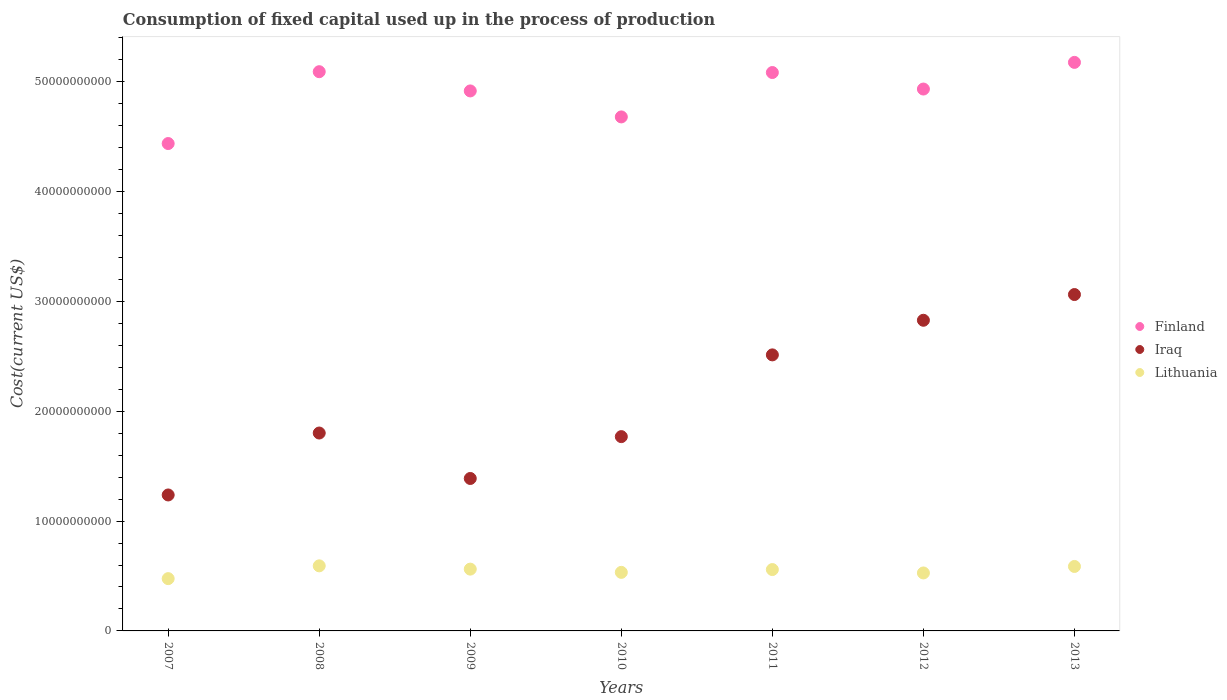Is the number of dotlines equal to the number of legend labels?
Keep it short and to the point. Yes. What is the amount consumed in the process of production in Iraq in 2008?
Keep it short and to the point. 1.80e+1. Across all years, what is the maximum amount consumed in the process of production in Lithuania?
Give a very brief answer. 5.93e+09. Across all years, what is the minimum amount consumed in the process of production in Lithuania?
Keep it short and to the point. 4.76e+09. In which year was the amount consumed in the process of production in Iraq maximum?
Make the answer very short. 2013. In which year was the amount consumed in the process of production in Lithuania minimum?
Provide a succinct answer. 2007. What is the total amount consumed in the process of production in Lithuania in the graph?
Make the answer very short. 3.84e+1. What is the difference between the amount consumed in the process of production in Finland in 2011 and that in 2012?
Give a very brief answer. 1.50e+09. What is the difference between the amount consumed in the process of production in Finland in 2011 and the amount consumed in the process of production in Lithuania in 2007?
Keep it short and to the point. 4.61e+1. What is the average amount consumed in the process of production in Iraq per year?
Make the answer very short. 2.09e+1. In the year 2012, what is the difference between the amount consumed in the process of production in Finland and amount consumed in the process of production in Lithuania?
Ensure brevity in your answer.  4.41e+1. What is the ratio of the amount consumed in the process of production in Iraq in 2008 to that in 2013?
Keep it short and to the point. 0.59. Is the amount consumed in the process of production in Iraq in 2008 less than that in 2013?
Give a very brief answer. Yes. Is the difference between the amount consumed in the process of production in Finland in 2009 and 2012 greater than the difference between the amount consumed in the process of production in Lithuania in 2009 and 2012?
Offer a very short reply. No. What is the difference between the highest and the second highest amount consumed in the process of production in Lithuania?
Your answer should be very brief. 5.58e+07. What is the difference between the highest and the lowest amount consumed in the process of production in Lithuania?
Make the answer very short. 1.16e+09. In how many years, is the amount consumed in the process of production in Finland greater than the average amount consumed in the process of production in Finland taken over all years?
Keep it short and to the point. 5. Does the amount consumed in the process of production in Iraq monotonically increase over the years?
Provide a succinct answer. No. How many dotlines are there?
Offer a terse response. 3. How many years are there in the graph?
Keep it short and to the point. 7. What is the difference between two consecutive major ticks on the Y-axis?
Keep it short and to the point. 1.00e+1. Where does the legend appear in the graph?
Your answer should be compact. Center right. How are the legend labels stacked?
Provide a short and direct response. Vertical. What is the title of the graph?
Your answer should be compact. Consumption of fixed capital used up in the process of production. What is the label or title of the Y-axis?
Provide a short and direct response. Cost(current US$). What is the Cost(current US$) of Finland in 2007?
Your answer should be compact. 4.44e+1. What is the Cost(current US$) in Iraq in 2007?
Your response must be concise. 1.24e+1. What is the Cost(current US$) in Lithuania in 2007?
Offer a terse response. 4.76e+09. What is the Cost(current US$) of Finland in 2008?
Offer a terse response. 5.09e+1. What is the Cost(current US$) of Iraq in 2008?
Provide a short and direct response. 1.80e+1. What is the Cost(current US$) of Lithuania in 2008?
Keep it short and to the point. 5.93e+09. What is the Cost(current US$) of Finland in 2009?
Provide a short and direct response. 4.92e+1. What is the Cost(current US$) in Iraq in 2009?
Keep it short and to the point. 1.39e+1. What is the Cost(current US$) of Lithuania in 2009?
Your answer should be compact. 5.63e+09. What is the Cost(current US$) in Finland in 2010?
Ensure brevity in your answer.  4.68e+1. What is the Cost(current US$) of Iraq in 2010?
Make the answer very short. 1.77e+1. What is the Cost(current US$) in Lithuania in 2010?
Your answer should be very brief. 5.33e+09. What is the Cost(current US$) in Finland in 2011?
Provide a succinct answer. 5.08e+1. What is the Cost(current US$) in Iraq in 2011?
Your answer should be very brief. 2.51e+1. What is the Cost(current US$) of Lithuania in 2011?
Ensure brevity in your answer.  5.59e+09. What is the Cost(current US$) of Finland in 2012?
Your answer should be compact. 4.93e+1. What is the Cost(current US$) of Iraq in 2012?
Offer a very short reply. 2.83e+1. What is the Cost(current US$) of Lithuania in 2012?
Provide a short and direct response. 5.28e+09. What is the Cost(current US$) in Finland in 2013?
Your response must be concise. 5.18e+1. What is the Cost(current US$) of Iraq in 2013?
Provide a short and direct response. 3.06e+1. What is the Cost(current US$) of Lithuania in 2013?
Your answer should be very brief. 5.87e+09. Across all years, what is the maximum Cost(current US$) of Finland?
Make the answer very short. 5.18e+1. Across all years, what is the maximum Cost(current US$) of Iraq?
Make the answer very short. 3.06e+1. Across all years, what is the maximum Cost(current US$) of Lithuania?
Provide a short and direct response. 5.93e+09. Across all years, what is the minimum Cost(current US$) in Finland?
Keep it short and to the point. 4.44e+1. Across all years, what is the minimum Cost(current US$) of Iraq?
Keep it short and to the point. 1.24e+1. Across all years, what is the minimum Cost(current US$) in Lithuania?
Offer a very short reply. 4.76e+09. What is the total Cost(current US$) in Finland in the graph?
Make the answer very short. 3.43e+11. What is the total Cost(current US$) of Iraq in the graph?
Offer a terse response. 1.46e+11. What is the total Cost(current US$) of Lithuania in the graph?
Keep it short and to the point. 3.84e+1. What is the difference between the Cost(current US$) in Finland in 2007 and that in 2008?
Your answer should be compact. -6.54e+09. What is the difference between the Cost(current US$) in Iraq in 2007 and that in 2008?
Keep it short and to the point. -5.64e+09. What is the difference between the Cost(current US$) of Lithuania in 2007 and that in 2008?
Provide a short and direct response. -1.16e+09. What is the difference between the Cost(current US$) in Finland in 2007 and that in 2009?
Provide a succinct answer. -4.79e+09. What is the difference between the Cost(current US$) in Iraq in 2007 and that in 2009?
Offer a very short reply. -1.50e+09. What is the difference between the Cost(current US$) in Lithuania in 2007 and that in 2009?
Ensure brevity in your answer.  -8.66e+08. What is the difference between the Cost(current US$) in Finland in 2007 and that in 2010?
Your response must be concise. -2.42e+09. What is the difference between the Cost(current US$) in Iraq in 2007 and that in 2010?
Keep it short and to the point. -5.31e+09. What is the difference between the Cost(current US$) of Lithuania in 2007 and that in 2010?
Your answer should be very brief. -5.70e+08. What is the difference between the Cost(current US$) in Finland in 2007 and that in 2011?
Your response must be concise. -6.47e+09. What is the difference between the Cost(current US$) in Iraq in 2007 and that in 2011?
Ensure brevity in your answer.  -1.28e+1. What is the difference between the Cost(current US$) of Lithuania in 2007 and that in 2011?
Your response must be concise. -8.25e+08. What is the difference between the Cost(current US$) of Finland in 2007 and that in 2012?
Your answer should be very brief. -4.96e+09. What is the difference between the Cost(current US$) in Iraq in 2007 and that in 2012?
Ensure brevity in your answer.  -1.59e+1. What is the difference between the Cost(current US$) in Lithuania in 2007 and that in 2012?
Your answer should be very brief. -5.17e+08. What is the difference between the Cost(current US$) in Finland in 2007 and that in 2013?
Your answer should be compact. -7.39e+09. What is the difference between the Cost(current US$) of Iraq in 2007 and that in 2013?
Your answer should be very brief. -1.83e+1. What is the difference between the Cost(current US$) of Lithuania in 2007 and that in 2013?
Your response must be concise. -1.11e+09. What is the difference between the Cost(current US$) of Finland in 2008 and that in 2009?
Your answer should be compact. 1.75e+09. What is the difference between the Cost(current US$) of Iraq in 2008 and that in 2009?
Your answer should be compact. 4.14e+09. What is the difference between the Cost(current US$) in Lithuania in 2008 and that in 2009?
Make the answer very short. 2.99e+08. What is the difference between the Cost(current US$) in Finland in 2008 and that in 2010?
Offer a terse response. 4.12e+09. What is the difference between the Cost(current US$) of Iraq in 2008 and that in 2010?
Keep it short and to the point. 3.27e+08. What is the difference between the Cost(current US$) of Lithuania in 2008 and that in 2010?
Your response must be concise. 5.94e+08. What is the difference between the Cost(current US$) in Finland in 2008 and that in 2011?
Your answer should be compact. 7.64e+07. What is the difference between the Cost(current US$) of Iraq in 2008 and that in 2011?
Provide a short and direct response. -7.12e+09. What is the difference between the Cost(current US$) of Lithuania in 2008 and that in 2011?
Provide a short and direct response. 3.39e+08. What is the difference between the Cost(current US$) in Finland in 2008 and that in 2012?
Your answer should be very brief. 1.58e+09. What is the difference between the Cost(current US$) of Iraq in 2008 and that in 2012?
Your answer should be very brief. -1.03e+1. What is the difference between the Cost(current US$) in Lithuania in 2008 and that in 2012?
Keep it short and to the point. 6.47e+08. What is the difference between the Cost(current US$) of Finland in 2008 and that in 2013?
Provide a succinct answer. -8.47e+08. What is the difference between the Cost(current US$) in Iraq in 2008 and that in 2013?
Offer a terse response. -1.26e+1. What is the difference between the Cost(current US$) in Lithuania in 2008 and that in 2013?
Your answer should be compact. 5.58e+07. What is the difference between the Cost(current US$) of Finland in 2009 and that in 2010?
Give a very brief answer. 2.37e+09. What is the difference between the Cost(current US$) in Iraq in 2009 and that in 2010?
Ensure brevity in your answer.  -3.81e+09. What is the difference between the Cost(current US$) of Lithuania in 2009 and that in 2010?
Provide a succinct answer. 2.95e+08. What is the difference between the Cost(current US$) of Finland in 2009 and that in 2011?
Provide a succinct answer. -1.68e+09. What is the difference between the Cost(current US$) in Iraq in 2009 and that in 2011?
Provide a succinct answer. -1.13e+1. What is the difference between the Cost(current US$) of Lithuania in 2009 and that in 2011?
Your answer should be very brief. 4.00e+07. What is the difference between the Cost(current US$) in Finland in 2009 and that in 2012?
Your answer should be compact. -1.72e+08. What is the difference between the Cost(current US$) in Iraq in 2009 and that in 2012?
Ensure brevity in your answer.  -1.44e+1. What is the difference between the Cost(current US$) in Lithuania in 2009 and that in 2012?
Offer a very short reply. 3.49e+08. What is the difference between the Cost(current US$) in Finland in 2009 and that in 2013?
Ensure brevity in your answer.  -2.60e+09. What is the difference between the Cost(current US$) in Iraq in 2009 and that in 2013?
Your answer should be very brief. -1.68e+1. What is the difference between the Cost(current US$) of Lithuania in 2009 and that in 2013?
Give a very brief answer. -2.43e+08. What is the difference between the Cost(current US$) of Finland in 2010 and that in 2011?
Your answer should be compact. -4.04e+09. What is the difference between the Cost(current US$) of Iraq in 2010 and that in 2011?
Your response must be concise. -7.44e+09. What is the difference between the Cost(current US$) in Lithuania in 2010 and that in 2011?
Your response must be concise. -2.55e+08. What is the difference between the Cost(current US$) in Finland in 2010 and that in 2012?
Offer a very short reply. -2.54e+09. What is the difference between the Cost(current US$) of Iraq in 2010 and that in 2012?
Offer a terse response. -1.06e+1. What is the difference between the Cost(current US$) of Lithuania in 2010 and that in 2012?
Your answer should be compact. 5.30e+07. What is the difference between the Cost(current US$) in Finland in 2010 and that in 2013?
Provide a short and direct response. -4.97e+09. What is the difference between the Cost(current US$) in Iraq in 2010 and that in 2013?
Provide a short and direct response. -1.29e+1. What is the difference between the Cost(current US$) in Lithuania in 2010 and that in 2013?
Provide a succinct answer. -5.38e+08. What is the difference between the Cost(current US$) of Finland in 2011 and that in 2012?
Give a very brief answer. 1.50e+09. What is the difference between the Cost(current US$) in Iraq in 2011 and that in 2012?
Provide a succinct answer. -3.15e+09. What is the difference between the Cost(current US$) in Lithuania in 2011 and that in 2012?
Provide a succinct answer. 3.08e+08. What is the difference between the Cost(current US$) in Finland in 2011 and that in 2013?
Offer a terse response. -9.24e+08. What is the difference between the Cost(current US$) in Iraq in 2011 and that in 2013?
Provide a succinct answer. -5.50e+09. What is the difference between the Cost(current US$) in Lithuania in 2011 and that in 2013?
Make the answer very short. -2.83e+08. What is the difference between the Cost(current US$) in Finland in 2012 and that in 2013?
Make the answer very short. -2.43e+09. What is the difference between the Cost(current US$) of Iraq in 2012 and that in 2013?
Keep it short and to the point. -2.34e+09. What is the difference between the Cost(current US$) in Lithuania in 2012 and that in 2013?
Ensure brevity in your answer.  -5.92e+08. What is the difference between the Cost(current US$) of Finland in 2007 and the Cost(current US$) of Iraq in 2008?
Ensure brevity in your answer.  2.64e+1. What is the difference between the Cost(current US$) of Finland in 2007 and the Cost(current US$) of Lithuania in 2008?
Ensure brevity in your answer.  3.85e+1. What is the difference between the Cost(current US$) in Iraq in 2007 and the Cost(current US$) in Lithuania in 2008?
Your answer should be compact. 6.45e+09. What is the difference between the Cost(current US$) of Finland in 2007 and the Cost(current US$) of Iraq in 2009?
Provide a succinct answer. 3.05e+1. What is the difference between the Cost(current US$) in Finland in 2007 and the Cost(current US$) in Lithuania in 2009?
Provide a short and direct response. 3.88e+1. What is the difference between the Cost(current US$) in Iraq in 2007 and the Cost(current US$) in Lithuania in 2009?
Offer a terse response. 6.75e+09. What is the difference between the Cost(current US$) in Finland in 2007 and the Cost(current US$) in Iraq in 2010?
Provide a succinct answer. 2.67e+1. What is the difference between the Cost(current US$) of Finland in 2007 and the Cost(current US$) of Lithuania in 2010?
Provide a succinct answer. 3.91e+1. What is the difference between the Cost(current US$) of Iraq in 2007 and the Cost(current US$) of Lithuania in 2010?
Provide a short and direct response. 7.05e+09. What is the difference between the Cost(current US$) of Finland in 2007 and the Cost(current US$) of Iraq in 2011?
Provide a succinct answer. 1.92e+1. What is the difference between the Cost(current US$) in Finland in 2007 and the Cost(current US$) in Lithuania in 2011?
Make the answer very short. 3.88e+1. What is the difference between the Cost(current US$) of Iraq in 2007 and the Cost(current US$) of Lithuania in 2011?
Keep it short and to the point. 6.79e+09. What is the difference between the Cost(current US$) of Finland in 2007 and the Cost(current US$) of Iraq in 2012?
Ensure brevity in your answer.  1.61e+1. What is the difference between the Cost(current US$) of Finland in 2007 and the Cost(current US$) of Lithuania in 2012?
Provide a succinct answer. 3.91e+1. What is the difference between the Cost(current US$) in Iraq in 2007 and the Cost(current US$) in Lithuania in 2012?
Your response must be concise. 7.10e+09. What is the difference between the Cost(current US$) in Finland in 2007 and the Cost(current US$) in Iraq in 2013?
Provide a short and direct response. 1.38e+1. What is the difference between the Cost(current US$) in Finland in 2007 and the Cost(current US$) in Lithuania in 2013?
Offer a terse response. 3.85e+1. What is the difference between the Cost(current US$) in Iraq in 2007 and the Cost(current US$) in Lithuania in 2013?
Ensure brevity in your answer.  6.51e+09. What is the difference between the Cost(current US$) in Finland in 2008 and the Cost(current US$) in Iraq in 2009?
Make the answer very short. 3.70e+1. What is the difference between the Cost(current US$) in Finland in 2008 and the Cost(current US$) in Lithuania in 2009?
Your response must be concise. 4.53e+1. What is the difference between the Cost(current US$) in Iraq in 2008 and the Cost(current US$) in Lithuania in 2009?
Your answer should be very brief. 1.24e+1. What is the difference between the Cost(current US$) of Finland in 2008 and the Cost(current US$) of Iraq in 2010?
Your response must be concise. 3.32e+1. What is the difference between the Cost(current US$) of Finland in 2008 and the Cost(current US$) of Lithuania in 2010?
Make the answer very short. 4.56e+1. What is the difference between the Cost(current US$) of Iraq in 2008 and the Cost(current US$) of Lithuania in 2010?
Provide a succinct answer. 1.27e+1. What is the difference between the Cost(current US$) in Finland in 2008 and the Cost(current US$) in Iraq in 2011?
Ensure brevity in your answer.  2.58e+1. What is the difference between the Cost(current US$) of Finland in 2008 and the Cost(current US$) of Lithuania in 2011?
Offer a terse response. 4.53e+1. What is the difference between the Cost(current US$) in Iraq in 2008 and the Cost(current US$) in Lithuania in 2011?
Give a very brief answer. 1.24e+1. What is the difference between the Cost(current US$) of Finland in 2008 and the Cost(current US$) of Iraq in 2012?
Ensure brevity in your answer.  2.26e+1. What is the difference between the Cost(current US$) of Finland in 2008 and the Cost(current US$) of Lithuania in 2012?
Ensure brevity in your answer.  4.56e+1. What is the difference between the Cost(current US$) of Iraq in 2008 and the Cost(current US$) of Lithuania in 2012?
Your answer should be very brief. 1.27e+1. What is the difference between the Cost(current US$) of Finland in 2008 and the Cost(current US$) of Iraq in 2013?
Provide a short and direct response. 2.03e+1. What is the difference between the Cost(current US$) in Finland in 2008 and the Cost(current US$) in Lithuania in 2013?
Keep it short and to the point. 4.51e+1. What is the difference between the Cost(current US$) in Iraq in 2008 and the Cost(current US$) in Lithuania in 2013?
Provide a short and direct response. 1.22e+1. What is the difference between the Cost(current US$) of Finland in 2009 and the Cost(current US$) of Iraq in 2010?
Offer a terse response. 3.15e+1. What is the difference between the Cost(current US$) in Finland in 2009 and the Cost(current US$) in Lithuania in 2010?
Ensure brevity in your answer.  4.38e+1. What is the difference between the Cost(current US$) in Iraq in 2009 and the Cost(current US$) in Lithuania in 2010?
Ensure brevity in your answer.  8.55e+09. What is the difference between the Cost(current US$) in Finland in 2009 and the Cost(current US$) in Iraq in 2011?
Keep it short and to the point. 2.40e+1. What is the difference between the Cost(current US$) of Finland in 2009 and the Cost(current US$) of Lithuania in 2011?
Your answer should be compact. 4.36e+1. What is the difference between the Cost(current US$) in Iraq in 2009 and the Cost(current US$) in Lithuania in 2011?
Give a very brief answer. 8.29e+09. What is the difference between the Cost(current US$) of Finland in 2009 and the Cost(current US$) of Iraq in 2012?
Offer a terse response. 2.09e+1. What is the difference between the Cost(current US$) in Finland in 2009 and the Cost(current US$) in Lithuania in 2012?
Make the answer very short. 4.39e+1. What is the difference between the Cost(current US$) of Iraq in 2009 and the Cost(current US$) of Lithuania in 2012?
Ensure brevity in your answer.  8.60e+09. What is the difference between the Cost(current US$) in Finland in 2009 and the Cost(current US$) in Iraq in 2013?
Offer a very short reply. 1.85e+1. What is the difference between the Cost(current US$) of Finland in 2009 and the Cost(current US$) of Lithuania in 2013?
Provide a succinct answer. 4.33e+1. What is the difference between the Cost(current US$) in Iraq in 2009 and the Cost(current US$) in Lithuania in 2013?
Ensure brevity in your answer.  8.01e+09. What is the difference between the Cost(current US$) of Finland in 2010 and the Cost(current US$) of Iraq in 2011?
Provide a short and direct response. 2.17e+1. What is the difference between the Cost(current US$) in Finland in 2010 and the Cost(current US$) in Lithuania in 2011?
Provide a short and direct response. 4.12e+1. What is the difference between the Cost(current US$) in Iraq in 2010 and the Cost(current US$) in Lithuania in 2011?
Give a very brief answer. 1.21e+1. What is the difference between the Cost(current US$) of Finland in 2010 and the Cost(current US$) of Iraq in 2012?
Ensure brevity in your answer.  1.85e+1. What is the difference between the Cost(current US$) of Finland in 2010 and the Cost(current US$) of Lithuania in 2012?
Provide a short and direct response. 4.15e+1. What is the difference between the Cost(current US$) in Iraq in 2010 and the Cost(current US$) in Lithuania in 2012?
Make the answer very short. 1.24e+1. What is the difference between the Cost(current US$) in Finland in 2010 and the Cost(current US$) in Iraq in 2013?
Offer a very short reply. 1.62e+1. What is the difference between the Cost(current US$) of Finland in 2010 and the Cost(current US$) of Lithuania in 2013?
Give a very brief answer. 4.09e+1. What is the difference between the Cost(current US$) of Iraq in 2010 and the Cost(current US$) of Lithuania in 2013?
Provide a short and direct response. 1.18e+1. What is the difference between the Cost(current US$) of Finland in 2011 and the Cost(current US$) of Iraq in 2012?
Provide a short and direct response. 2.26e+1. What is the difference between the Cost(current US$) of Finland in 2011 and the Cost(current US$) of Lithuania in 2012?
Offer a very short reply. 4.56e+1. What is the difference between the Cost(current US$) of Iraq in 2011 and the Cost(current US$) of Lithuania in 2012?
Offer a very short reply. 1.99e+1. What is the difference between the Cost(current US$) in Finland in 2011 and the Cost(current US$) in Iraq in 2013?
Your response must be concise. 2.02e+1. What is the difference between the Cost(current US$) of Finland in 2011 and the Cost(current US$) of Lithuania in 2013?
Keep it short and to the point. 4.50e+1. What is the difference between the Cost(current US$) of Iraq in 2011 and the Cost(current US$) of Lithuania in 2013?
Make the answer very short. 1.93e+1. What is the difference between the Cost(current US$) of Finland in 2012 and the Cost(current US$) of Iraq in 2013?
Give a very brief answer. 1.87e+1. What is the difference between the Cost(current US$) of Finland in 2012 and the Cost(current US$) of Lithuania in 2013?
Your answer should be very brief. 4.35e+1. What is the difference between the Cost(current US$) in Iraq in 2012 and the Cost(current US$) in Lithuania in 2013?
Your response must be concise. 2.24e+1. What is the average Cost(current US$) in Finland per year?
Offer a very short reply. 4.90e+1. What is the average Cost(current US$) in Iraq per year?
Your response must be concise. 2.09e+1. What is the average Cost(current US$) of Lithuania per year?
Your answer should be very brief. 5.48e+09. In the year 2007, what is the difference between the Cost(current US$) of Finland and Cost(current US$) of Iraq?
Ensure brevity in your answer.  3.20e+1. In the year 2007, what is the difference between the Cost(current US$) in Finland and Cost(current US$) in Lithuania?
Make the answer very short. 3.96e+1. In the year 2007, what is the difference between the Cost(current US$) of Iraq and Cost(current US$) of Lithuania?
Offer a terse response. 7.62e+09. In the year 2008, what is the difference between the Cost(current US$) in Finland and Cost(current US$) in Iraq?
Keep it short and to the point. 3.29e+1. In the year 2008, what is the difference between the Cost(current US$) in Finland and Cost(current US$) in Lithuania?
Provide a short and direct response. 4.50e+1. In the year 2008, what is the difference between the Cost(current US$) in Iraq and Cost(current US$) in Lithuania?
Provide a short and direct response. 1.21e+1. In the year 2009, what is the difference between the Cost(current US$) in Finland and Cost(current US$) in Iraq?
Provide a succinct answer. 3.53e+1. In the year 2009, what is the difference between the Cost(current US$) in Finland and Cost(current US$) in Lithuania?
Ensure brevity in your answer.  4.35e+1. In the year 2009, what is the difference between the Cost(current US$) in Iraq and Cost(current US$) in Lithuania?
Offer a terse response. 8.25e+09. In the year 2010, what is the difference between the Cost(current US$) of Finland and Cost(current US$) of Iraq?
Offer a very short reply. 2.91e+1. In the year 2010, what is the difference between the Cost(current US$) in Finland and Cost(current US$) in Lithuania?
Ensure brevity in your answer.  4.15e+1. In the year 2010, what is the difference between the Cost(current US$) of Iraq and Cost(current US$) of Lithuania?
Your answer should be compact. 1.24e+1. In the year 2011, what is the difference between the Cost(current US$) of Finland and Cost(current US$) of Iraq?
Your answer should be compact. 2.57e+1. In the year 2011, what is the difference between the Cost(current US$) in Finland and Cost(current US$) in Lithuania?
Provide a short and direct response. 4.53e+1. In the year 2011, what is the difference between the Cost(current US$) in Iraq and Cost(current US$) in Lithuania?
Give a very brief answer. 1.95e+1. In the year 2012, what is the difference between the Cost(current US$) in Finland and Cost(current US$) in Iraq?
Ensure brevity in your answer.  2.11e+1. In the year 2012, what is the difference between the Cost(current US$) of Finland and Cost(current US$) of Lithuania?
Offer a terse response. 4.41e+1. In the year 2012, what is the difference between the Cost(current US$) of Iraq and Cost(current US$) of Lithuania?
Ensure brevity in your answer.  2.30e+1. In the year 2013, what is the difference between the Cost(current US$) of Finland and Cost(current US$) of Iraq?
Your answer should be very brief. 2.11e+1. In the year 2013, what is the difference between the Cost(current US$) of Finland and Cost(current US$) of Lithuania?
Provide a short and direct response. 4.59e+1. In the year 2013, what is the difference between the Cost(current US$) of Iraq and Cost(current US$) of Lithuania?
Offer a terse response. 2.48e+1. What is the ratio of the Cost(current US$) of Finland in 2007 to that in 2008?
Provide a short and direct response. 0.87. What is the ratio of the Cost(current US$) of Iraq in 2007 to that in 2008?
Your response must be concise. 0.69. What is the ratio of the Cost(current US$) of Lithuania in 2007 to that in 2008?
Your answer should be compact. 0.8. What is the ratio of the Cost(current US$) in Finland in 2007 to that in 2009?
Your response must be concise. 0.9. What is the ratio of the Cost(current US$) in Iraq in 2007 to that in 2009?
Your answer should be compact. 0.89. What is the ratio of the Cost(current US$) of Lithuania in 2007 to that in 2009?
Provide a succinct answer. 0.85. What is the ratio of the Cost(current US$) in Finland in 2007 to that in 2010?
Provide a succinct answer. 0.95. What is the ratio of the Cost(current US$) of Iraq in 2007 to that in 2010?
Provide a short and direct response. 0.7. What is the ratio of the Cost(current US$) in Lithuania in 2007 to that in 2010?
Offer a very short reply. 0.89. What is the ratio of the Cost(current US$) in Finland in 2007 to that in 2011?
Make the answer very short. 0.87. What is the ratio of the Cost(current US$) in Iraq in 2007 to that in 2011?
Offer a very short reply. 0.49. What is the ratio of the Cost(current US$) of Lithuania in 2007 to that in 2011?
Offer a terse response. 0.85. What is the ratio of the Cost(current US$) in Finland in 2007 to that in 2012?
Make the answer very short. 0.9. What is the ratio of the Cost(current US$) in Iraq in 2007 to that in 2012?
Provide a short and direct response. 0.44. What is the ratio of the Cost(current US$) in Lithuania in 2007 to that in 2012?
Ensure brevity in your answer.  0.9. What is the ratio of the Cost(current US$) of Finland in 2007 to that in 2013?
Provide a succinct answer. 0.86. What is the ratio of the Cost(current US$) of Iraq in 2007 to that in 2013?
Offer a terse response. 0.4. What is the ratio of the Cost(current US$) in Lithuania in 2007 to that in 2013?
Provide a succinct answer. 0.81. What is the ratio of the Cost(current US$) in Finland in 2008 to that in 2009?
Give a very brief answer. 1.04. What is the ratio of the Cost(current US$) of Iraq in 2008 to that in 2009?
Provide a short and direct response. 1.3. What is the ratio of the Cost(current US$) in Lithuania in 2008 to that in 2009?
Your response must be concise. 1.05. What is the ratio of the Cost(current US$) of Finland in 2008 to that in 2010?
Make the answer very short. 1.09. What is the ratio of the Cost(current US$) in Iraq in 2008 to that in 2010?
Keep it short and to the point. 1.02. What is the ratio of the Cost(current US$) in Lithuania in 2008 to that in 2010?
Offer a very short reply. 1.11. What is the ratio of the Cost(current US$) in Iraq in 2008 to that in 2011?
Give a very brief answer. 0.72. What is the ratio of the Cost(current US$) in Lithuania in 2008 to that in 2011?
Ensure brevity in your answer.  1.06. What is the ratio of the Cost(current US$) in Finland in 2008 to that in 2012?
Offer a terse response. 1.03. What is the ratio of the Cost(current US$) of Iraq in 2008 to that in 2012?
Your answer should be very brief. 0.64. What is the ratio of the Cost(current US$) in Lithuania in 2008 to that in 2012?
Give a very brief answer. 1.12. What is the ratio of the Cost(current US$) in Finland in 2008 to that in 2013?
Make the answer very short. 0.98. What is the ratio of the Cost(current US$) in Iraq in 2008 to that in 2013?
Your answer should be compact. 0.59. What is the ratio of the Cost(current US$) of Lithuania in 2008 to that in 2013?
Your answer should be very brief. 1.01. What is the ratio of the Cost(current US$) of Finland in 2009 to that in 2010?
Give a very brief answer. 1.05. What is the ratio of the Cost(current US$) in Iraq in 2009 to that in 2010?
Your answer should be compact. 0.78. What is the ratio of the Cost(current US$) in Lithuania in 2009 to that in 2010?
Offer a very short reply. 1.06. What is the ratio of the Cost(current US$) of Iraq in 2009 to that in 2011?
Provide a short and direct response. 0.55. What is the ratio of the Cost(current US$) in Lithuania in 2009 to that in 2011?
Give a very brief answer. 1.01. What is the ratio of the Cost(current US$) of Finland in 2009 to that in 2012?
Your answer should be very brief. 1. What is the ratio of the Cost(current US$) of Iraq in 2009 to that in 2012?
Your answer should be compact. 0.49. What is the ratio of the Cost(current US$) of Lithuania in 2009 to that in 2012?
Offer a very short reply. 1.07. What is the ratio of the Cost(current US$) in Finland in 2009 to that in 2013?
Make the answer very short. 0.95. What is the ratio of the Cost(current US$) of Iraq in 2009 to that in 2013?
Your answer should be very brief. 0.45. What is the ratio of the Cost(current US$) of Lithuania in 2009 to that in 2013?
Provide a short and direct response. 0.96. What is the ratio of the Cost(current US$) in Finland in 2010 to that in 2011?
Give a very brief answer. 0.92. What is the ratio of the Cost(current US$) in Iraq in 2010 to that in 2011?
Ensure brevity in your answer.  0.7. What is the ratio of the Cost(current US$) of Lithuania in 2010 to that in 2011?
Offer a very short reply. 0.95. What is the ratio of the Cost(current US$) in Finland in 2010 to that in 2012?
Make the answer very short. 0.95. What is the ratio of the Cost(current US$) of Iraq in 2010 to that in 2012?
Ensure brevity in your answer.  0.63. What is the ratio of the Cost(current US$) of Finland in 2010 to that in 2013?
Keep it short and to the point. 0.9. What is the ratio of the Cost(current US$) in Iraq in 2010 to that in 2013?
Provide a succinct answer. 0.58. What is the ratio of the Cost(current US$) of Lithuania in 2010 to that in 2013?
Provide a short and direct response. 0.91. What is the ratio of the Cost(current US$) in Finland in 2011 to that in 2012?
Provide a succinct answer. 1.03. What is the ratio of the Cost(current US$) in Iraq in 2011 to that in 2012?
Your response must be concise. 0.89. What is the ratio of the Cost(current US$) of Lithuania in 2011 to that in 2012?
Give a very brief answer. 1.06. What is the ratio of the Cost(current US$) in Finland in 2011 to that in 2013?
Your answer should be compact. 0.98. What is the ratio of the Cost(current US$) of Iraq in 2011 to that in 2013?
Give a very brief answer. 0.82. What is the ratio of the Cost(current US$) in Lithuania in 2011 to that in 2013?
Make the answer very short. 0.95. What is the ratio of the Cost(current US$) of Finland in 2012 to that in 2013?
Keep it short and to the point. 0.95. What is the ratio of the Cost(current US$) in Iraq in 2012 to that in 2013?
Offer a very short reply. 0.92. What is the ratio of the Cost(current US$) in Lithuania in 2012 to that in 2013?
Keep it short and to the point. 0.9. What is the difference between the highest and the second highest Cost(current US$) of Finland?
Make the answer very short. 8.47e+08. What is the difference between the highest and the second highest Cost(current US$) in Iraq?
Ensure brevity in your answer.  2.34e+09. What is the difference between the highest and the second highest Cost(current US$) in Lithuania?
Give a very brief answer. 5.58e+07. What is the difference between the highest and the lowest Cost(current US$) of Finland?
Ensure brevity in your answer.  7.39e+09. What is the difference between the highest and the lowest Cost(current US$) in Iraq?
Give a very brief answer. 1.83e+1. What is the difference between the highest and the lowest Cost(current US$) of Lithuania?
Your response must be concise. 1.16e+09. 